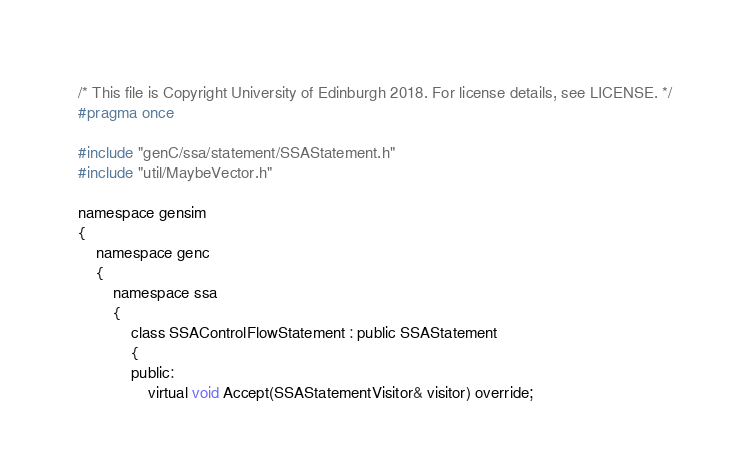<code> <loc_0><loc_0><loc_500><loc_500><_C_>/* This file is Copyright University of Edinburgh 2018. For license details, see LICENSE. */
#pragma once

#include "genC/ssa/statement/SSAStatement.h"
#include "util/MaybeVector.h"

namespace gensim
{
	namespace genc
	{
		namespace ssa
		{
			class SSAControlFlowStatement : public SSAStatement
			{
			public:
				virtual void Accept(SSAStatementVisitor& visitor) override;
</code> 